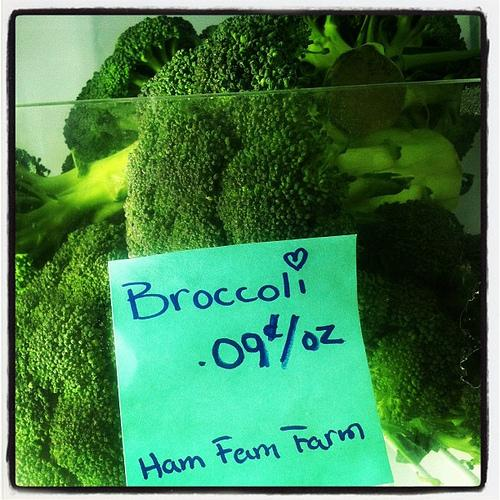Assess the quality of the image's main object, the broccoli. The broccoli is raw, very green, and appears to be of good quality. What type of writing utensil was likely used to pen the note in the image? A marker with blue ink was likely used to write the note. Describe the overall scene observed in the image. The image shows a broccoli being sold behind a pane of glass, with a blue paper note indicating its price and other details. State the type of divider enclosing the broccoli. The broccoli is enclosed in a clear plastic divider or plexiglass. What object does the blue heart appear on in the image? The blue heart is drawn on a piece of paper. Identify the vegetable being sold in the image and the price per ounce. Broccoli is being sold for 09 cents an ounce. List three colors mentioned on the broccoli in the image. Dark green, light green, and blue. What unique feature does the "i" have in the image text? The "i" is dotted with a heart. Provide the name of the farm where the broccoli comes from. The broccoli is from Ham Fam Farm. What is the predominant color of the note in the image? The predominant color of the note is blue. Is the note written with a pencil? The note is mentioned as being written with a marker, not a pencil. Is the white wall in the background yellow? The wall in the background is described as white, not yellow. Is the broccoli purple and orange? The broccoli is described as having dark and light green colors, not purple and orange. Is the plastic divider in the broccoli made of wood? The divider is described as plastic, not wood. Is the cent sign on the blue paper red? The cent sign on the blue paper is not red; it is mentioned that the writing (including the cent sign) is done using blue ink. Does the blue paper have a pink heart drawn on it? The blue paper has a blue heart drawn on it, not a pink one. 